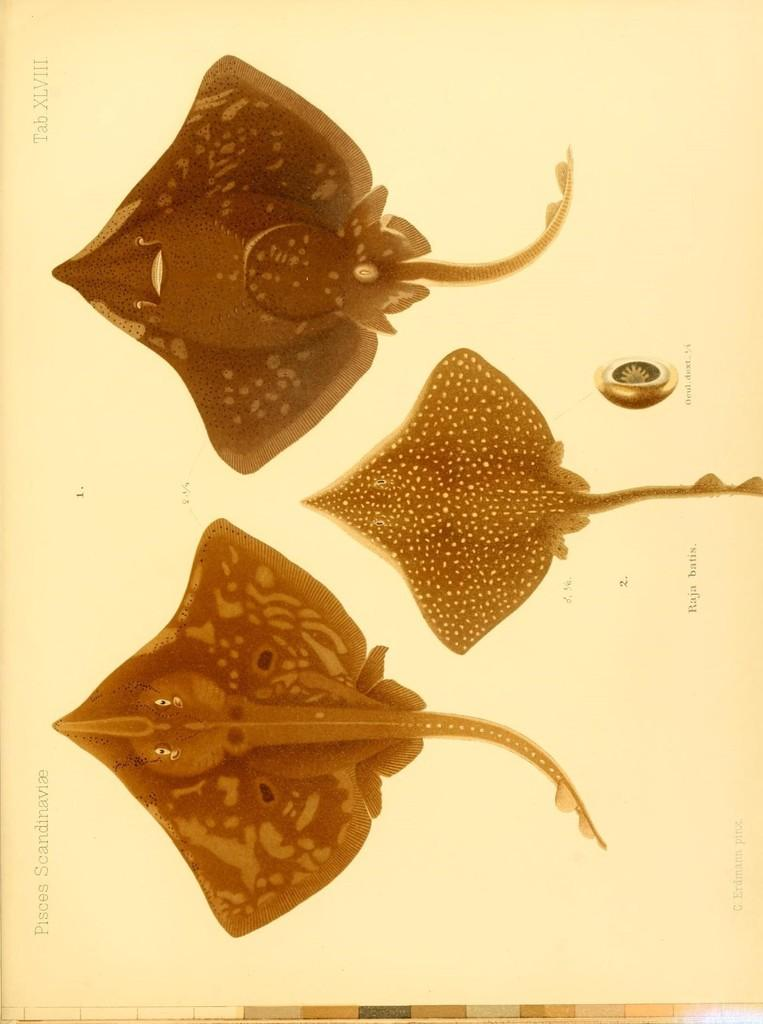What is the main subject of the paper in the image? The paper contains three ray fish images. What else can be seen on the paper besides the images? There is writing on the paper. How many cats are visible on the paper in the image? There are no cats visible on the paper in the image; it contains three ray fish images and writing. What type of belief is represented by the ladybug on the paper? There is no ladybug present on the paper in the image. 